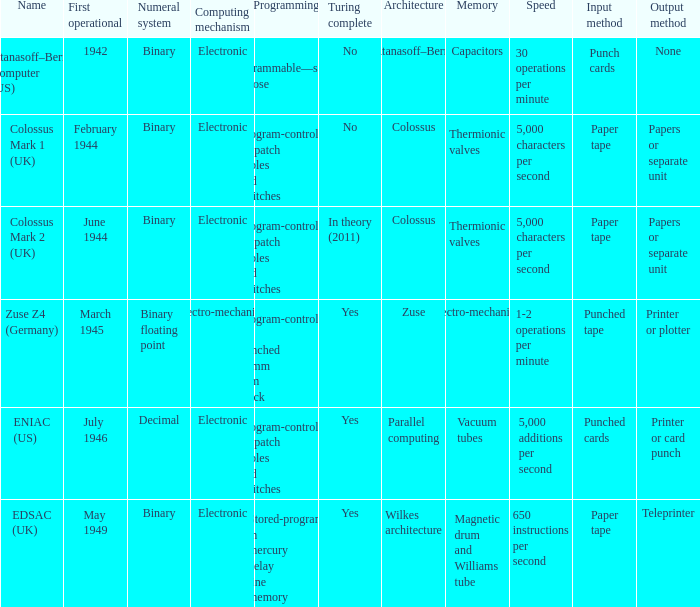What's the turing complete with name being atanasoff–berry computer (us) No. 